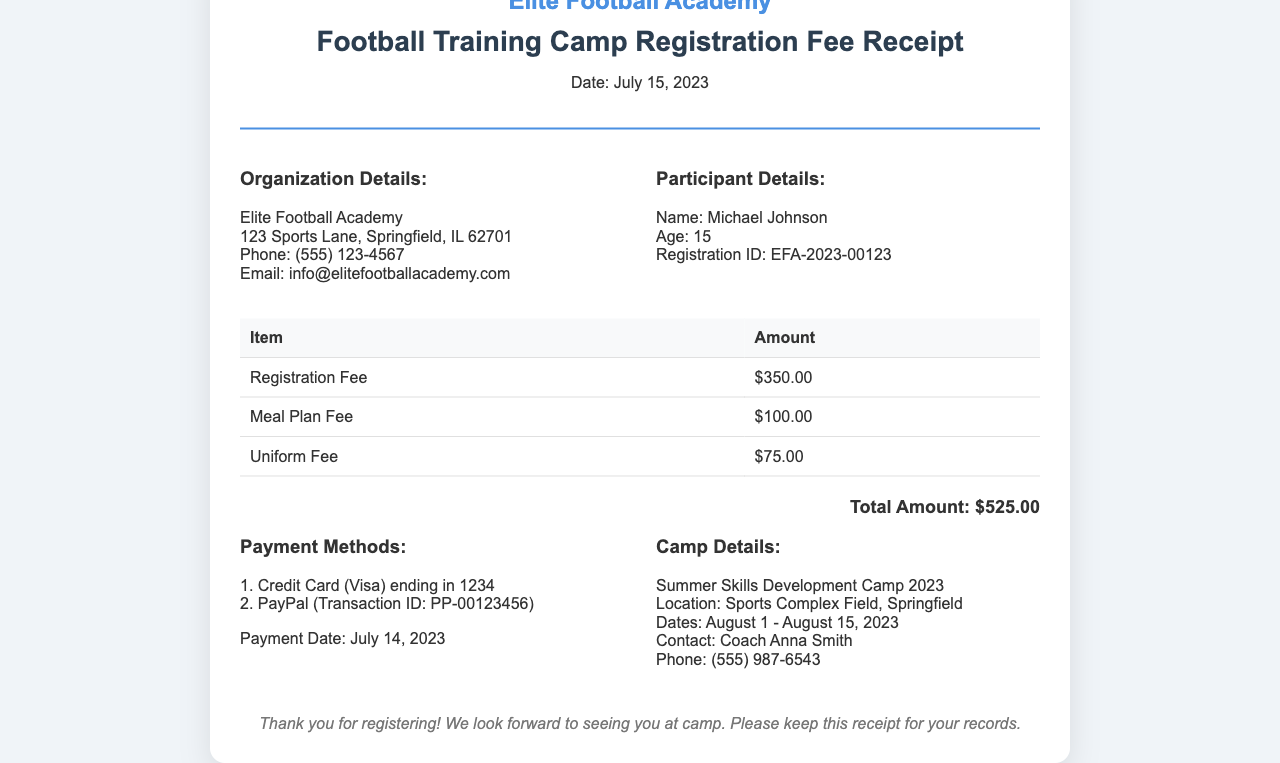What is the name of the participant? The participant's name is listed in the receipt under "Participant Details."
Answer: Michael Johnson What is the total amount due? The total amount can be found in the summary section at the bottom of the receipt.
Answer: $525.00 What is the registration ID? The registration ID for the participant is provided under "Participant Details."
Answer: EFA-2023-00123 When was the payment made? The payment date is specified in the "Payment Methods" section of the receipt.
Answer: July 14, 2023 What is the location of the training camp? The camp location is detailed in the "Camp Details" section.
Answer: Sports Complex Field, Springfield How many fees are listed on the receipt? There are three fees mentioned in the table: Registration Fee, Meal Plan Fee, and Uniform Fee.
Answer: Three What is the name of the academy? The academy's name is stated prominently at the top of the receipt.
Answer: Elite Football Academy Who is the contact person for the camp? The contact person is mentioned in the "Camp Details" section.
Answer: Coach Anna Smith What type of payment methods were used? The payment methods are listed under "Payment Methods."
Answer: Credit Card, PayPal 